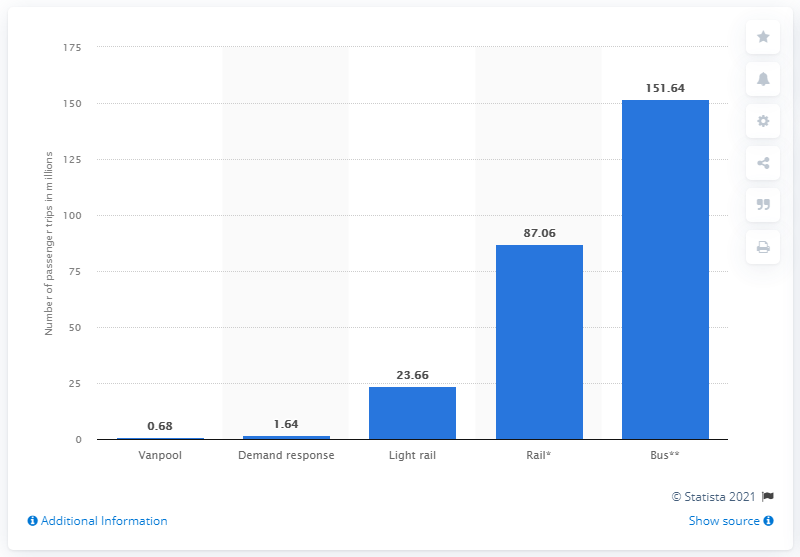Specify some key components in this picture. In 2018, NJ Transit reported a total of 23,660 unlinked passenger trips. 